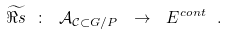<formula> <loc_0><loc_0><loc_500><loc_500>\widetilde { \Re s } \ \colon \ \mathcal { A } _ { \mathcal { C } \subset G / P } \ \to \ E ^ { c o n t } \ .</formula> 